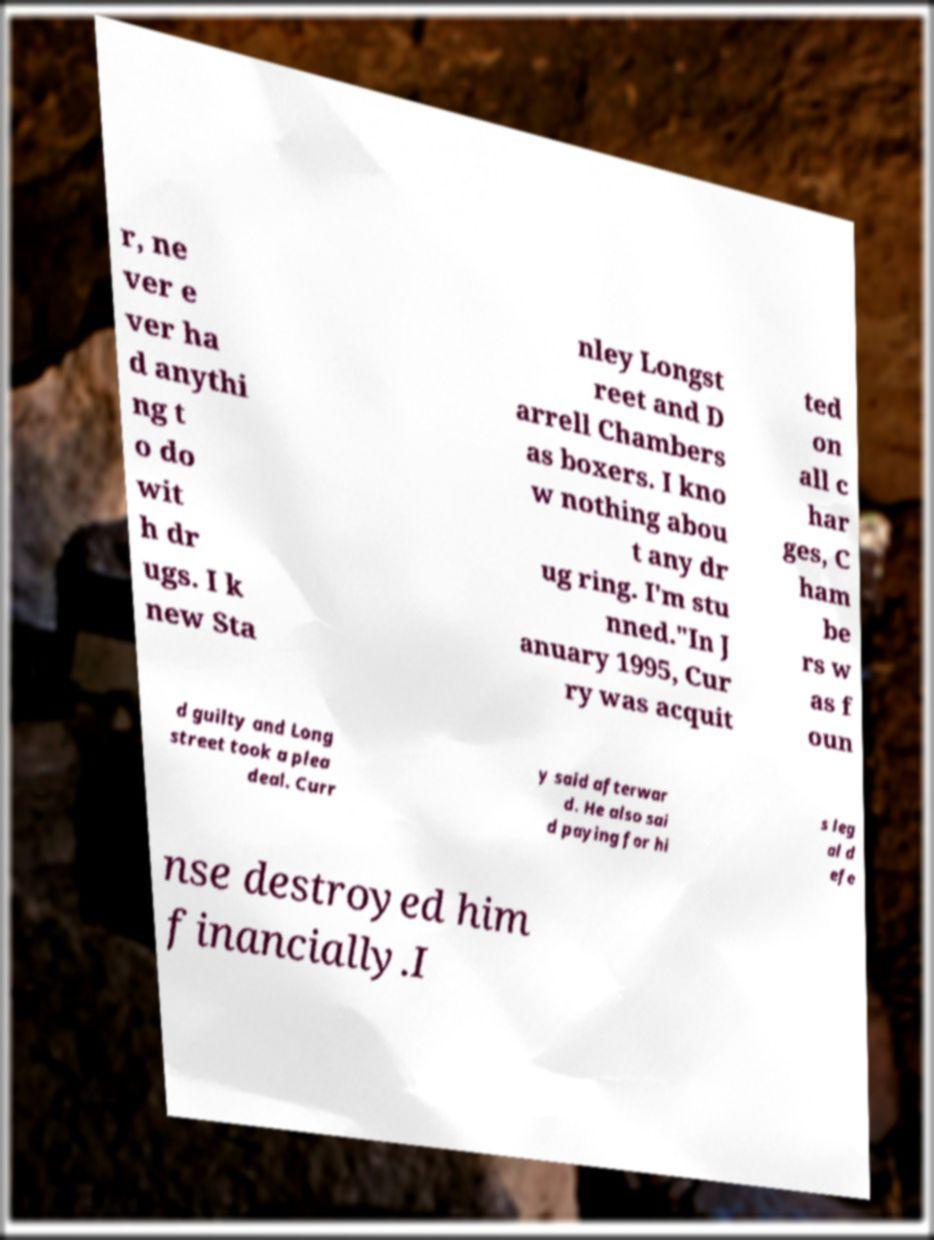I need the written content from this picture converted into text. Can you do that? r, ne ver e ver ha d anythi ng t o do wit h dr ugs. I k new Sta nley Longst reet and D arrell Chambers as boxers. I kno w nothing abou t any dr ug ring. I'm stu nned."In J anuary 1995, Cur ry was acquit ted on all c har ges, C ham be rs w as f oun d guilty and Long street took a plea deal. Curr y said afterwar d. He also sai d paying for hi s leg al d efe nse destroyed him financially.I 